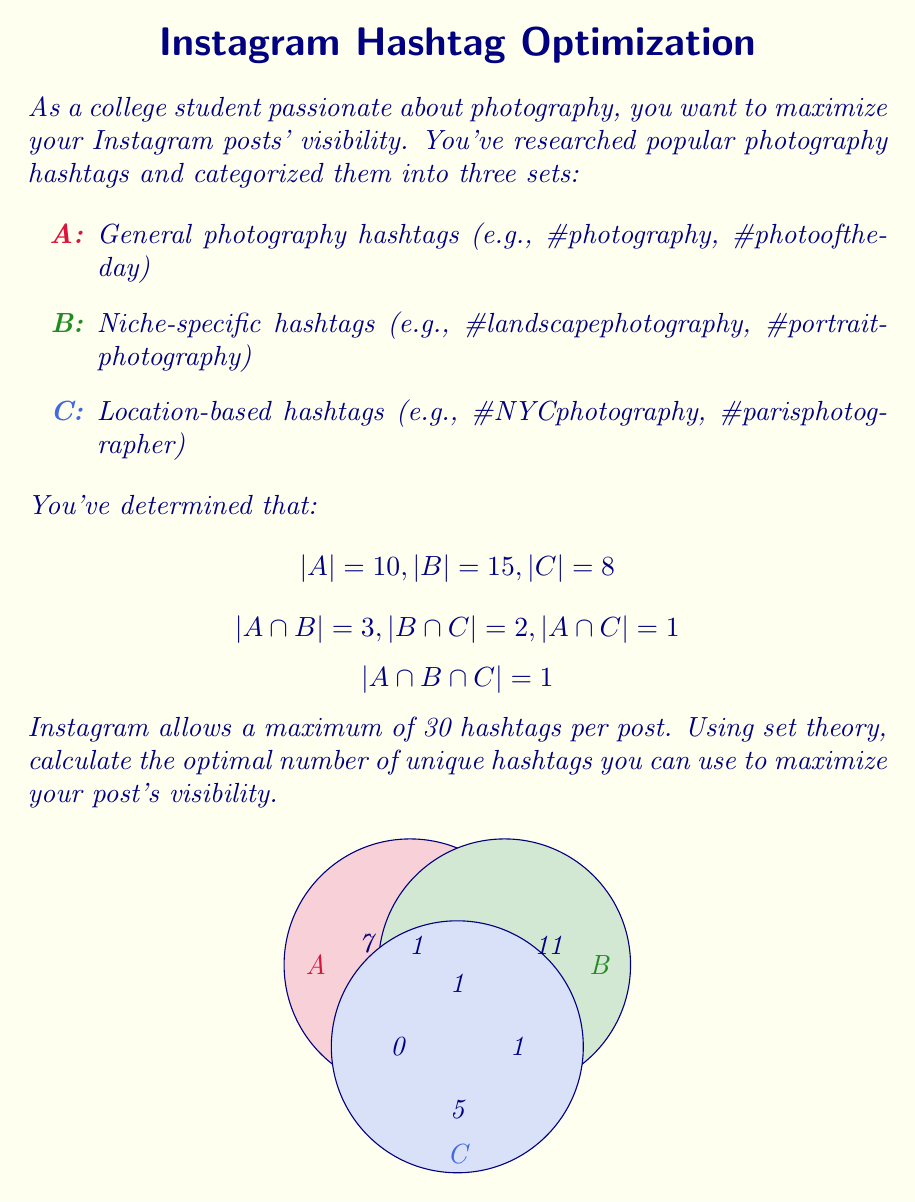Teach me how to tackle this problem. Let's approach this step-by-step using the principle of inclusion-exclusion:

1) First, we need to find the total number of unique hashtags. This is given by:

   $$|A \cup B \cup C| = |A| + |B| + |C| - |A \cap B| - |B \cap C| - |A \cap C| + |A \cap B \cap C|$$

2) Let's substitute the given values:

   $$|A \cup B \cup C| = 10 + 15 + 8 - 3 - 2 - 1 + 1$$

3) Simplify:

   $$|A \cup B \cup C| = 33 - 6 + 1 = 28$$

4) Therefore, the total number of unique hashtags available is 28.

5) Instagram allows a maximum of 30 hashtags per post. Since we have 28 unique hashtags, which is less than the maximum allowed, we can use all of them.

Thus, the optimal number of hashtags to use is 28, which will maximize the post's visibility by covering all unique hashtags across the three categories without exceeding Instagram's limit.
Answer: 28 hashtags 